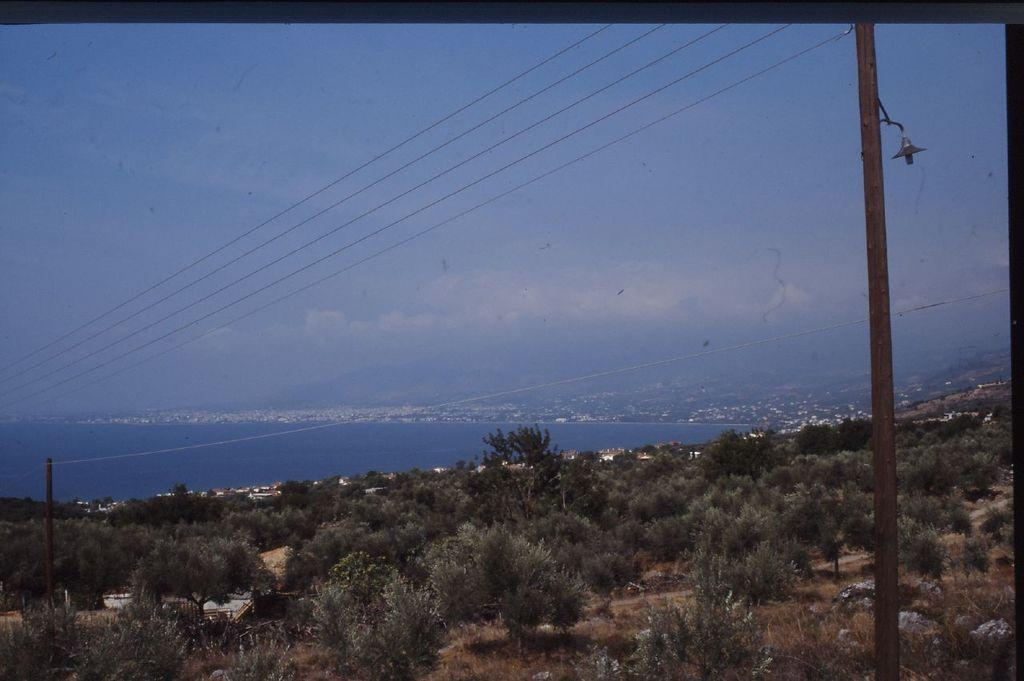What type of vegetation can be seen in the image? There are trees in the image. What structure is present in the image? There is a pole in the image. What else is present in the image besides the pole and trees? Wires are present in the image. What natural feature can be seen in the background of the image? There is a sea in the image. How would you describe the sky in the image? The sky is blue with clouds. How many cows are grazing near the sea in the image? There are no cows present in the image. What type of kettle is used to boil water in the image? There is no kettle present in the image. 